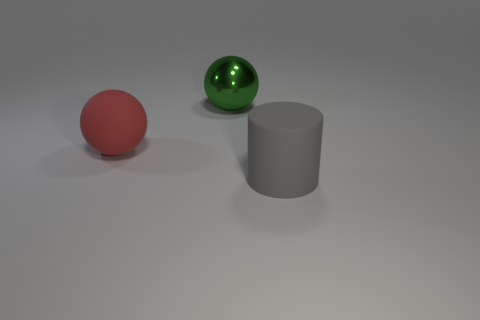Subtract 1 spheres. How many spheres are left? 1 Subtract all green spheres. How many spheres are left? 1 Add 2 blue objects. How many objects exist? 5 Subtract all cylinders. How many objects are left? 2 Add 2 large objects. How many large objects are left? 5 Add 2 big green metallic cylinders. How many big green metallic cylinders exist? 2 Subtract 0 blue cylinders. How many objects are left? 3 Subtract all blue spheres. Subtract all red blocks. How many spheres are left? 2 Subtract all tiny cyan matte balls. Subtract all shiny things. How many objects are left? 2 